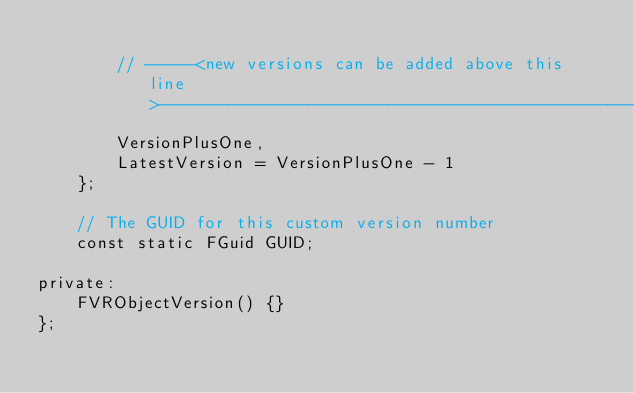<code> <loc_0><loc_0><loc_500><loc_500><_C_>
		// -----<new versions can be added above this line>-------------------------------------------------
		VersionPlusOne,
		LatestVersion = VersionPlusOne - 1
	};

	// The GUID for this custom version number
	const static FGuid GUID;

private:
	FVRObjectVersion() {}
};
</code> 